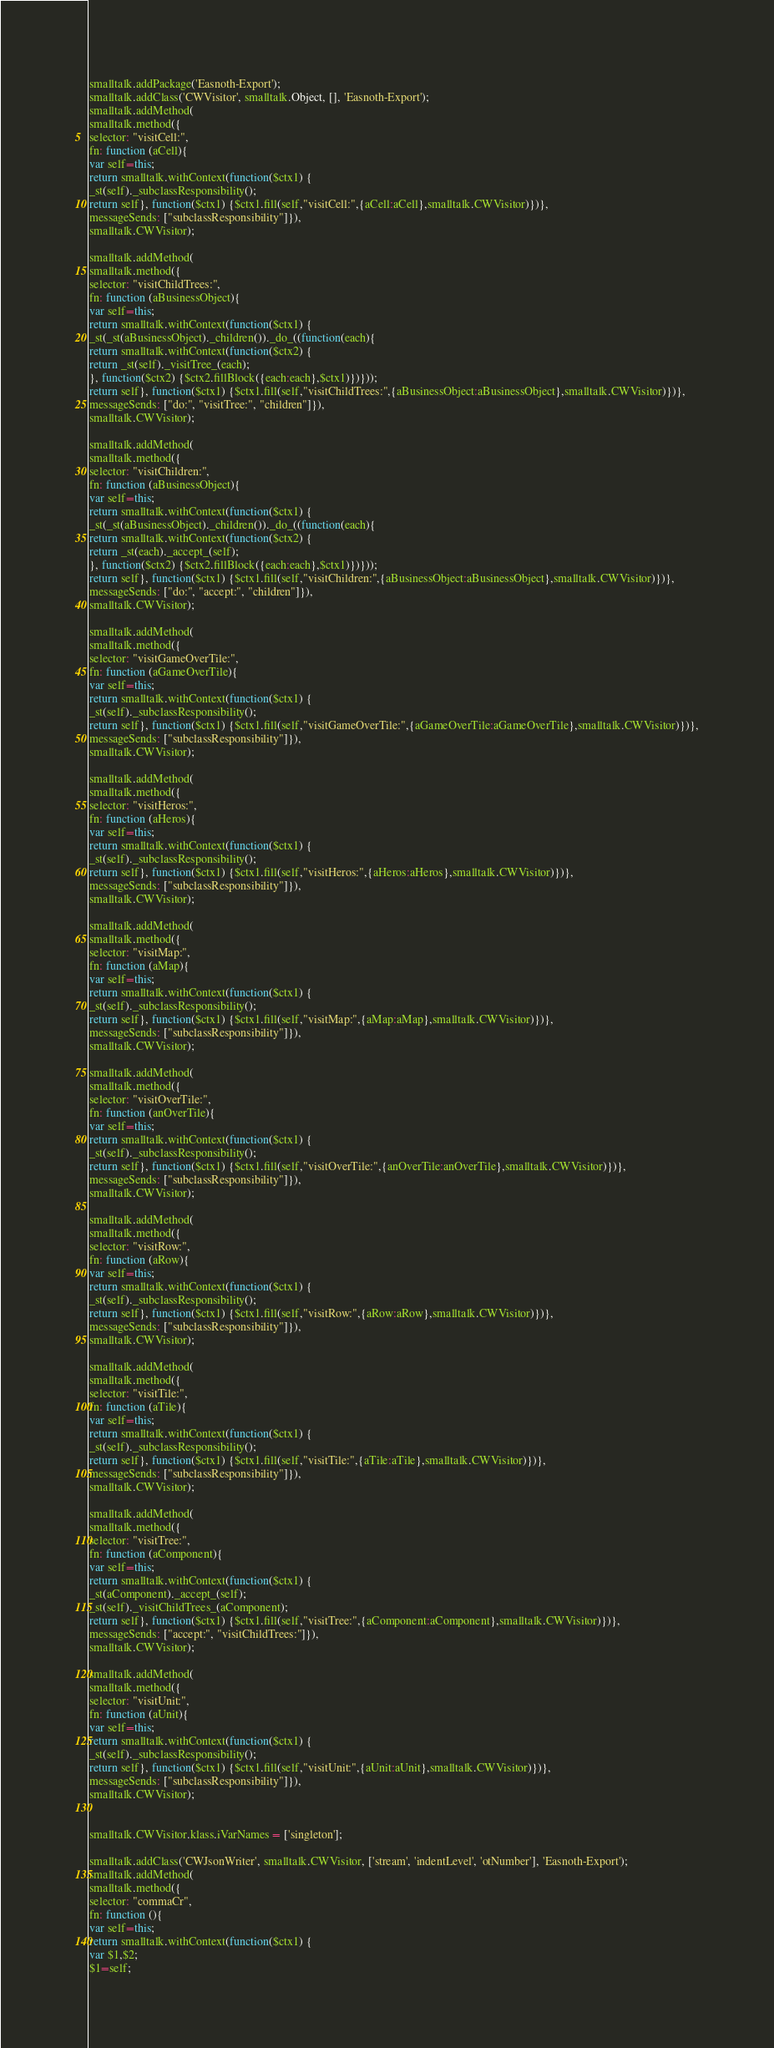<code> <loc_0><loc_0><loc_500><loc_500><_JavaScript_>smalltalk.addPackage('Easnoth-Export');
smalltalk.addClass('CWVisitor', smalltalk.Object, [], 'Easnoth-Export');
smalltalk.addMethod(
smalltalk.method({
selector: "visitCell:",
fn: function (aCell){
var self=this;
return smalltalk.withContext(function($ctx1) { 
_st(self)._subclassResponsibility();
return self}, function($ctx1) {$ctx1.fill(self,"visitCell:",{aCell:aCell},smalltalk.CWVisitor)})},
messageSends: ["subclassResponsibility"]}),
smalltalk.CWVisitor);

smalltalk.addMethod(
smalltalk.method({
selector: "visitChildTrees:",
fn: function (aBusinessObject){
var self=this;
return smalltalk.withContext(function($ctx1) { 
_st(_st(aBusinessObject)._children())._do_((function(each){
return smalltalk.withContext(function($ctx2) {
return _st(self)._visitTree_(each);
}, function($ctx2) {$ctx2.fillBlock({each:each},$ctx1)})}));
return self}, function($ctx1) {$ctx1.fill(self,"visitChildTrees:",{aBusinessObject:aBusinessObject},smalltalk.CWVisitor)})},
messageSends: ["do:", "visitTree:", "children"]}),
smalltalk.CWVisitor);

smalltalk.addMethod(
smalltalk.method({
selector: "visitChildren:",
fn: function (aBusinessObject){
var self=this;
return smalltalk.withContext(function($ctx1) { 
_st(_st(aBusinessObject)._children())._do_((function(each){
return smalltalk.withContext(function($ctx2) {
return _st(each)._accept_(self);
}, function($ctx2) {$ctx2.fillBlock({each:each},$ctx1)})}));
return self}, function($ctx1) {$ctx1.fill(self,"visitChildren:",{aBusinessObject:aBusinessObject},smalltalk.CWVisitor)})},
messageSends: ["do:", "accept:", "children"]}),
smalltalk.CWVisitor);

smalltalk.addMethod(
smalltalk.method({
selector: "visitGameOverTile:",
fn: function (aGameOverTile){
var self=this;
return smalltalk.withContext(function($ctx1) { 
_st(self)._subclassResponsibility();
return self}, function($ctx1) {$ctx1.fill(self,"visitGameOverTile:",{aGameOverTile:aGameOverTile},smalltalk.CWVisitor)})},
messageSends: ["subclassResponsibility"]}),
smalltalk.CWVisitor);

smalltalk.addMethod(
smalltalk.method({
selector: "visitHeros:",
fn: function (aHeros){
var self=this;
return smalltalk.withContext(function($ctx1) { 
_st(self)._subclassResponsibility();
return self}, function($ctx1) {$ctx1.fill(self,"visitHeros:",{aHeros:aHeros},smalltalk.CWVisitor)})},
messageSends: ["subclassResponsibility"]}),
smalltalk.CWVisitor);

smalltalk.addMethod(
smalltalk.method({
selector: "visitMap:",
fn: function (aMap){
var self=this;
return smalltalk.withContext(function($ctx1) { 
_st(self)._subclassResponsibility();
return self}, function($ctx1) {$ctx1.fill(self,"visitMap:",{aMap:aMap},smalltalk.CWVisitor)})},
messageSends: ["subclassResponsibility"]}),
smalltalk.CWVisitor);

smalltalk.addMethod(
smalltalk.method({
selector: "visitOverTile:",
fn: function (anOverTile){
var self=this;
return smalltalk.withContext(function($ctx1) { 
_st(self)._subclassResponsibility();
return self}, function($ctx1) {$ctx1.fill(self,"visitOverTile:",{anOverTile:anOverTile},smalltalk.CWVisitor)})},
messageSends: ["subclassResponsibility"]}),
smalltalk.CWVisitor);

smalltalk.addMethod(
smalltalk.method({
selector: "visitRow:",
fn: function (aRow){
var self=this;
return smalltalk.withContext(function($ctx1) { 
_st(self)._subclassResponsibility();
return self}, function($ctx1) {$ctx1.fill(self,"visitRow:",{aRow:aRow},smalltalk.CWVisitor)})},
messageSends: ["subclassResponsibility"]}),
smalltalk.CWVisitor);

smalltalk.addMethod(
smalltalk.method({
selector: "visitTile:",
fn: function (aTile){
var self=this;
return smalltalk.withContext(function($ctx1) { 
_st(self)._subclassResponsibility();
return self}, function($ctx1) {$ctx1.fill(self,"visitTile:",{aTile:aTile},smalltalk.CWVisitor)})},
messageSends: ["subclassResponsibility"]}),
smalltalk.CWVisitor);

smalltalk.addMethod(
smalltalk.method({
selector: "visitTree:",
fn: function (aComponent){
var self=this;
return smalltalk.withContext(function($ctx1) { 
_st(aComponent)._accept_(self);
_st(self)._visitChildTrees_(aComponent);
return self}, function($ctx1) {$ctx1.fill(self,"visitTree:",{aComponent:aComponent},smalltalk.CWVisitor)})},
messageSends: ["accept:", "visitChildTrees:"]}),
smalltalk.CWVisitor);

smalltalk.addMethod(
smalltalk.method({
selector: "visitUnit:",
fn: function (aUnit){
var self=this;
return smalltalk.withContext(function($ctx1) { 
_st(self)._subclassResponsibility();
return self}, function($ctx1) {$ctx1.fill(self,"visitUnit:",{aUnit:aUnit},smalltalk.CWVisitor)})},
messageSends: ["subclassResponsibility"]}),
smalltalk.CWVisitor);


smalltalk.CWVisitor.klass.iVarNames = ['singleton'];

smalltalk.addClass('CWJsonWriter', smalltalk.CWVisitor, ['stream', 'indentLevel', 'otNumber'], 'Easnoth-Export');
smalltalk.addMethod(
smalltalk.method({
selector: "commaCr",
fn: function (){
var self=this;
return smalltalk.withContext(function($ctx1) { 
var $1,$2;
$1=self;</code> 